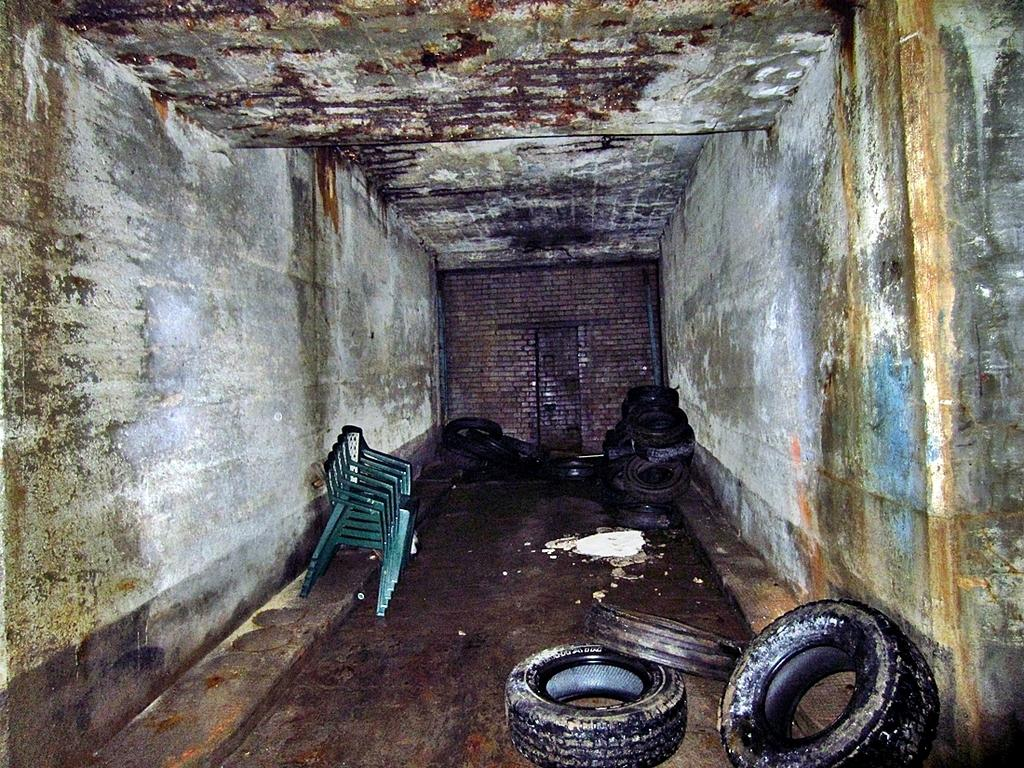What objects can be seen in the image? There are tires and chairs in the image. What is covering the walls in the image? There is green algae on the walls. What type of wall can be seen in the background of the image? There is a brick wall in the background of the image. What type of competition is taking place at the seashore in the image? There is no seashore or competition present in the image. What type of dinner is being served on the chairs in the image? There is no dinner or food visible in the image; only chairs and tires are present. 